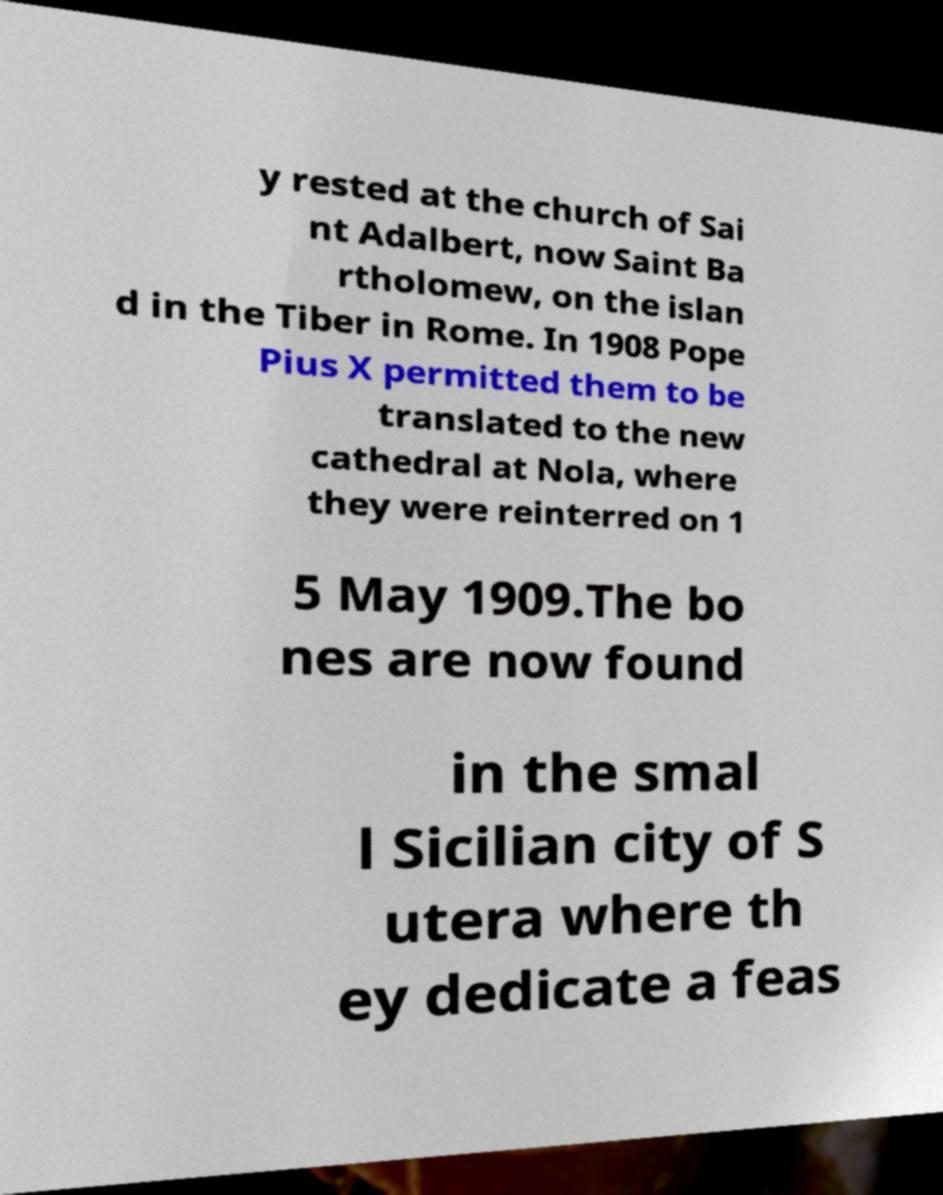Please identify and transcribe the text found in this image. y rested at the church of Sai nt Adalbert, now Saint Ba rtholomew, on the islan d in the Tiber in Rome. In 1908 Pope Pius X permitted them to be translated to the new cathedral at Nola, where they were reinterred on 1 5 May 1909.The bo nes are now found in the smal l Sicilian city of S utera where th ey dedicate a feas 